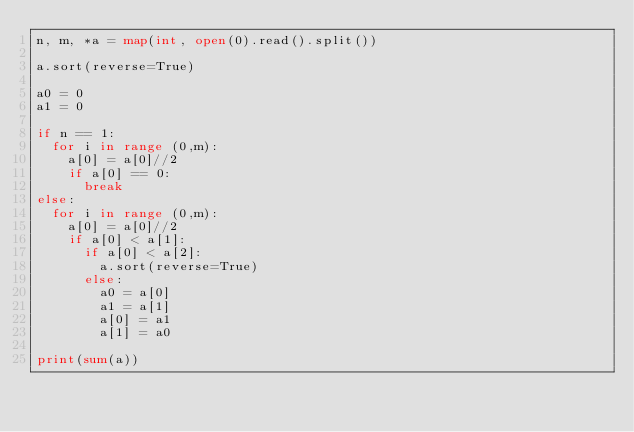<code> <loc_0><loc_0><loc_500><loc_500><_Python_>n, m, *a = map(int, open(0).read().split())

a.sort(reverse=True)

a0 = 0
a1 = 0

if n == 1:
  for i in range (0,m):
    a[0] = a[0]//2
    if a[0] == 0:
      break
else:
  for i in range (0,m):
    a[0] = a[0]//2
    if a[0] < a[1]:
      if a[0] < a[2]:
        a.sort(reverse=True)
      else:
        a0 = a[0]
        a1 = a[1]
        a[0] = a1
        a[1] = a0

print(sum(a))</code> 